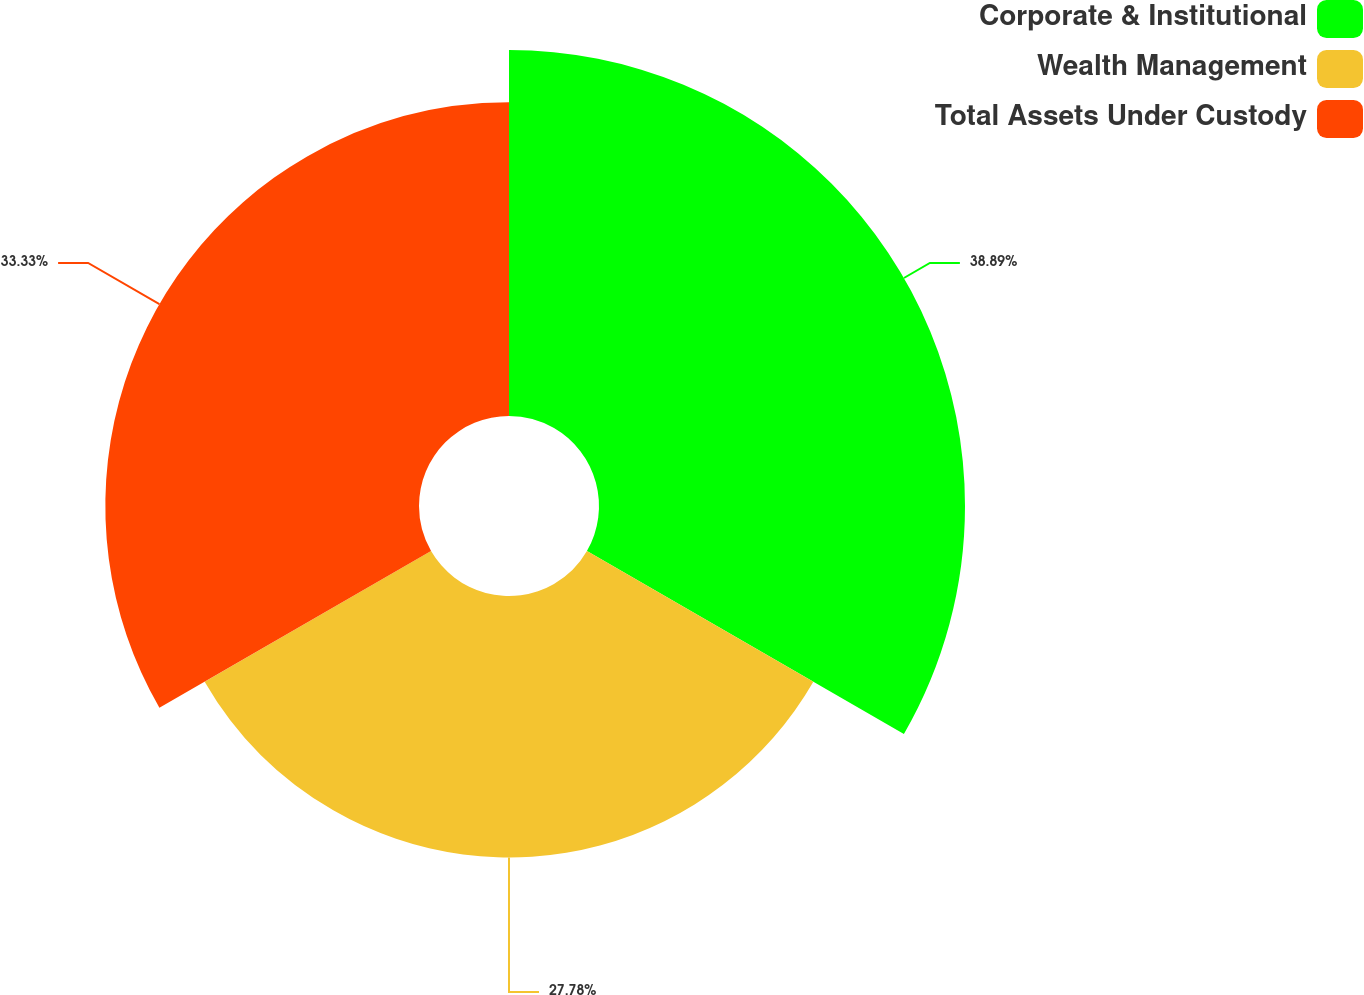<chart> <loc_0><loc_0><loc_500><loc_500><pie_chart><fcel>Corporate & Institutional<fcel>Wealth Management<fcel>Total Assets Under Custody<nl><fcel>38.89%<fcel>27.78%<fcel>33.33%<nl></chart> 